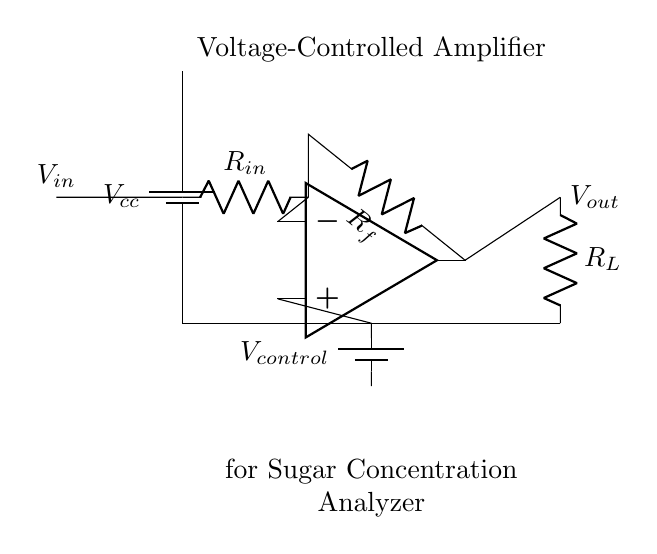What is the purpose of this circuit? The circuit is labeled as a Voltage-Controlled Amplifier for a sugar concentration analyzer, indicating its role in amplifying signals related to sugar measurement based on a control voltage.
Answer: Voltage-Controlled Amplifier for Sugar Concentration Analyzer What type of amplifier is represented here? The circuit diagram shows an operational amplifier configured as a voltage-controlled amplifier, suggesting the amplifier's behavior is controlled by a particular input voltage.
Answer: Operational amplifier What component determines the input resistance? The input resistance in this circuit is determined by the resistor labeled R_in, which is connected directly to the input signal.
Answer: R_in How does the control voltage affect the output? The control voltage V_control is applied to the non-inverting terminal of the operational amplifier, influencing the gain and subsequently the output voltage, thus adjusting the amplification based on the control signal.
Answer: Controls gain/output What is the relationship between R_f and V_out? The resistor R_f, connected in the feedback loop of the operational amplifier, sets the feedback factor that influences the gain of the amplifier, thereby affecting the output voltage V_out in relation to the input voltage V_in.
Answer: Sets gain of amplifier What is the output voltage connected to? The output voltage V_out is connected to a resistor labeled R_L, which completes the output circuit, effectively allowing the output signal to be delivered to the load.
Answer: R_L 